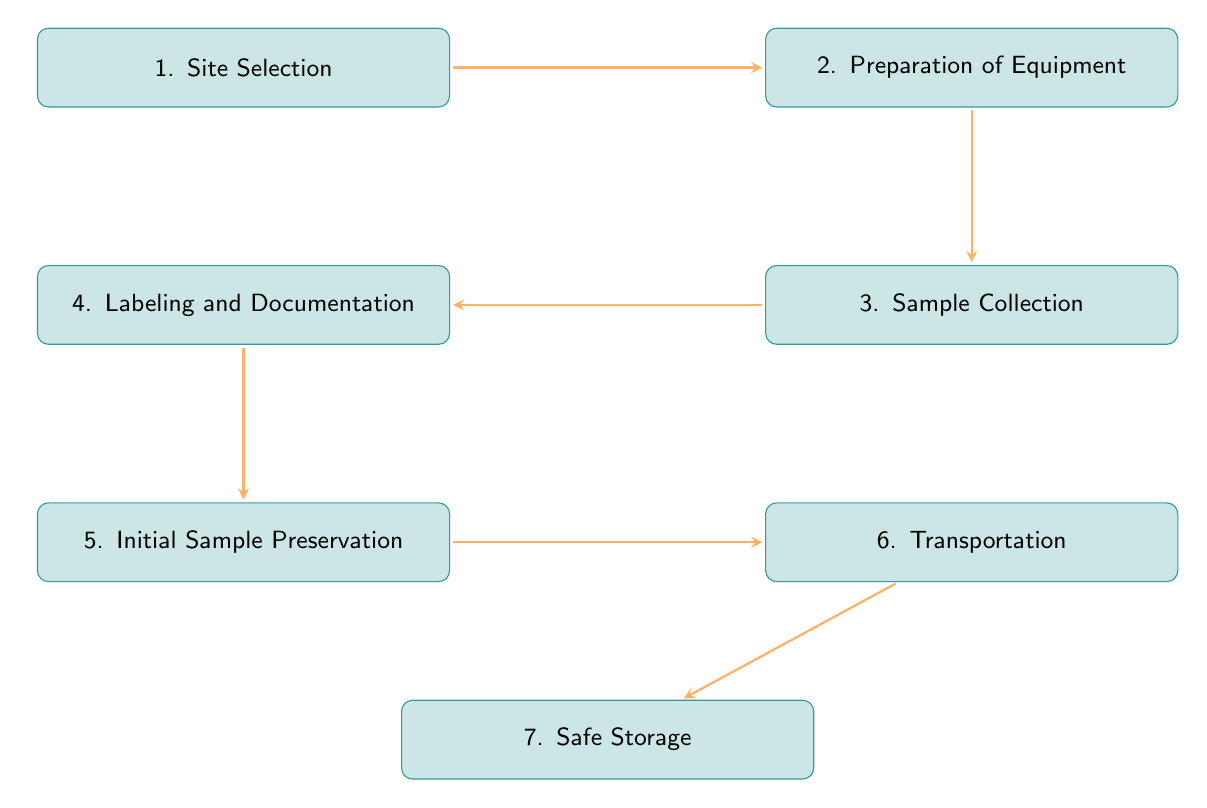What is the first step in the water sample collection process? The diagram indicates that the first step is "Site Selection." This is the node that appears at the top of the flow chart, clearly labeled as step 1.
Answer: Site Selection How many steps are there in the water sample collection process? By counting the nodes shown in the flow chart, I see that there are a total of 7 steps, starting from Site Selection and ending at Safe Storage.
Answer: 7 Which step involves the transportation of samples? The diagram shows that "Transportation" is the sixth step in the process, as indicated by its position and label in the flow chart.
Answer: Transportation What is the step immediately after Sample Collection? The flow chart shows that the step following "Sample Collection" is "Labeling and Documentation," which directly connects below it.
Answer: Labeling and Documentation What important consideration is mentioned during the Preparation of Equipment step? The step "Preparation of Equipment" mentions several important considerations; one of them is "Sterilization to prevent contamination." This is explicitly noted under the second step in the diagram.
Answer: Sterilization to prevent contamination Which steps involve preservation measures? The steps that involve preservation measures are "Initial Sample Preservation" and "Safe Storage." The flow of the diagram connects the preservation step that deals with chemicals and the final storage process together.
Answer: Initial Sample Preservation and Safe Storage What is required during the Initial Sample Preservation step? The diagram specifies that appropriate chemical preservatives are required in the "Initial Sample Preservation" step, along with maintaining controlled temperature conditions.
Answer: Appropriate chemical preservatives What follows Safe Storage in the flow chart? The flow chart indicates that "Safe Storage" is the last step, and there are no steps that follow it as it concludes this process.
Answer: None 